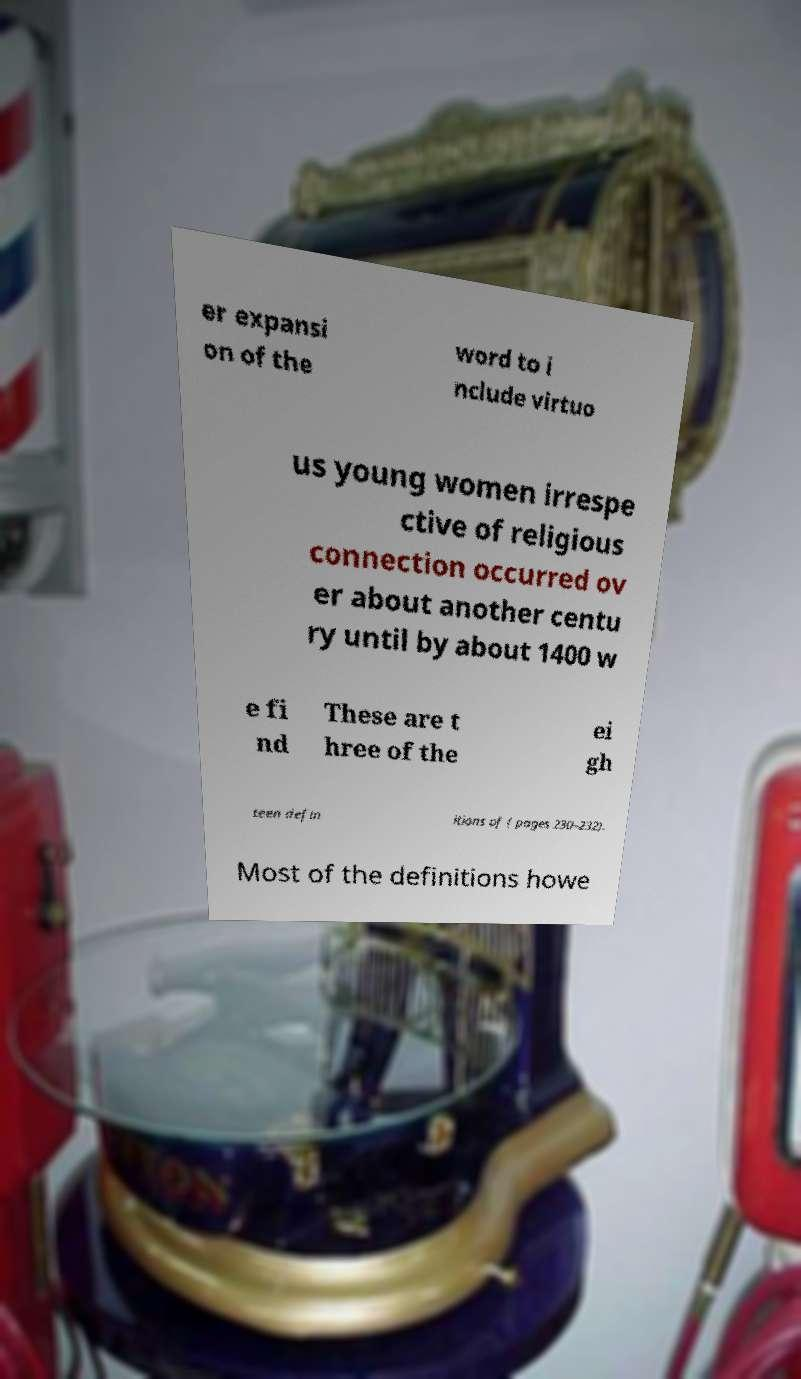Please identify and transcribe the text found in this image. er expansi on of the word to i nclude virtuo us young women irrespe ctive of religious connection occurred ov er about another centu ry until by about 1400 w e fi nd These are t hree of the ei gh teen defin itions of ( pages 230–232). Most of the definitions howe 